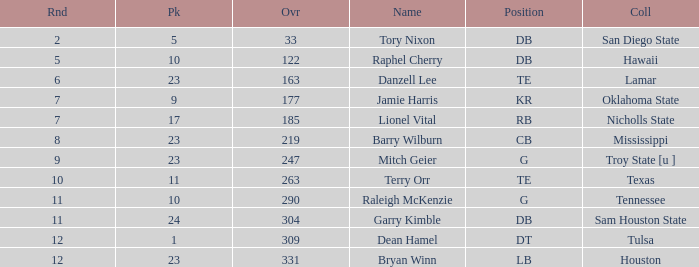How many Picks have an Overall smaller than 304, and a Position of g, and a Round smaller than 11? 1.0. 